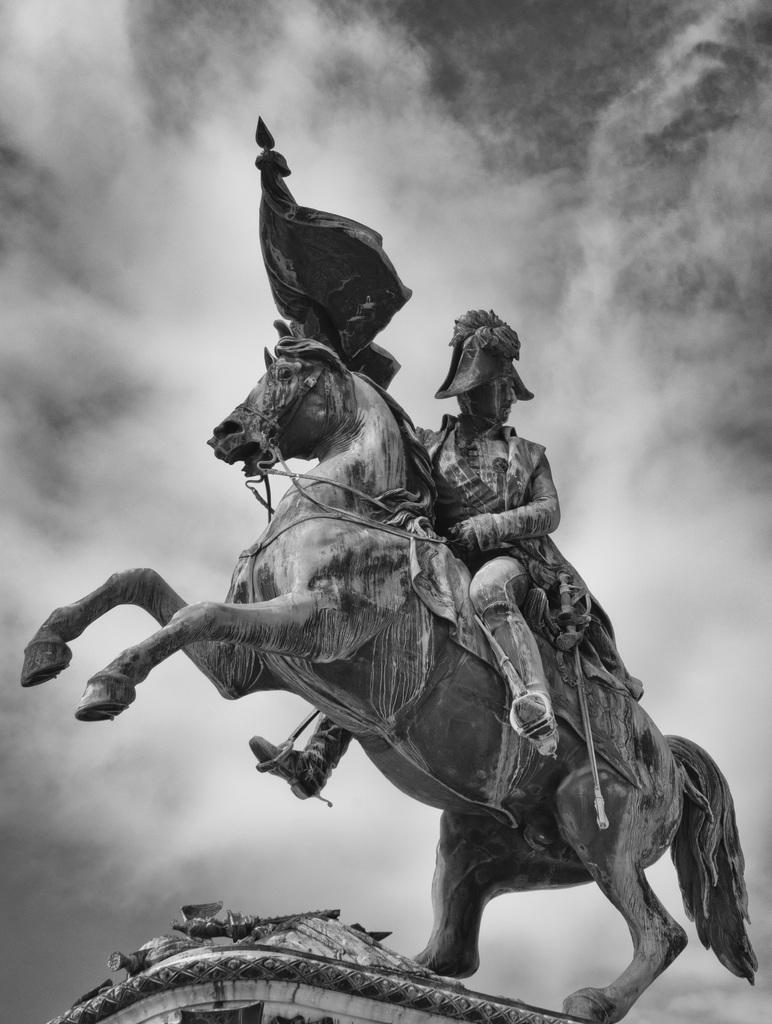What is the main subject of the picture? The main subject of the picture is a warrior statue. What is the warrior doing in the statue? The warrior is sitting on a horse. What is the horse doing in the statue? The horse is raising its two front legs. What is the warrior holding in the statue? The warrior is holding a flag in his hand. How would you describe the sky in the picture? The sky behind the statue is cloudy. Can you tell me how many goats are standing next to the statue in the image? There are no goats present in the image; the statue features a warrior sitting on a horse. What type of work is the warrior statue doing in the image? The warrior statue is not performing any work; it is a stationary sculpture. 